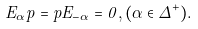Convert formula to latex. <formula><loc_0><loc_0><loc_500><loc_500>E _ { \alpha } p = p E _ { - \alpha } = 0 , ( \alpha \in \Delta ^ { + } ) .</formula> 